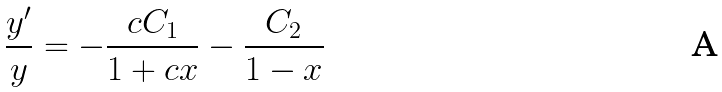<formula> <loc_0><loc_0><loc_500><loc_500>\frac { y ^ { \prime } } { y } = - \frac { c C _ { 1 } } { 1 + c x } - \frac { C _ { 2 } } { 1 - x }</formula> 